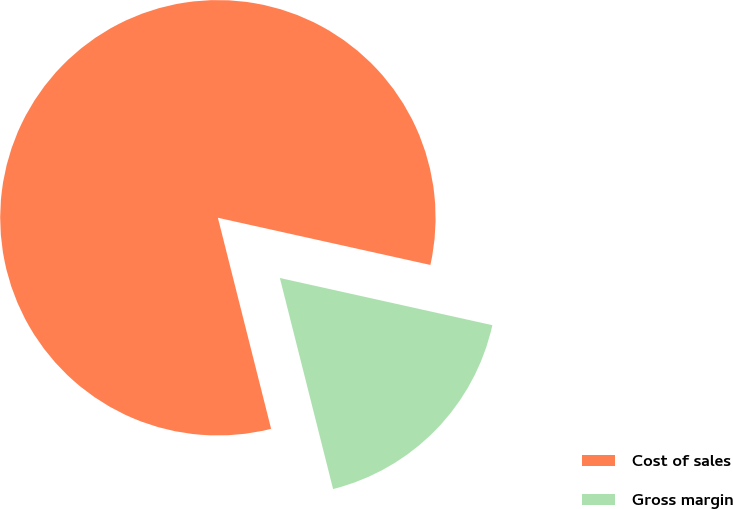Convert chart. <chart><loc_0><loc_0><loc_500><loc_500><pie_chart><fcel>Cost of sales<fcel>Gross margin<nl><fcel>82.41%<fcel>17.59%<nl></chart> 